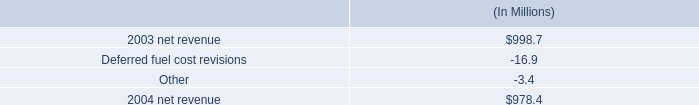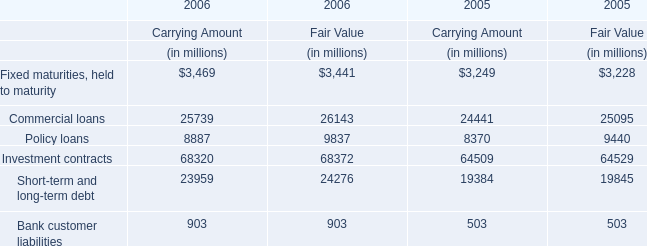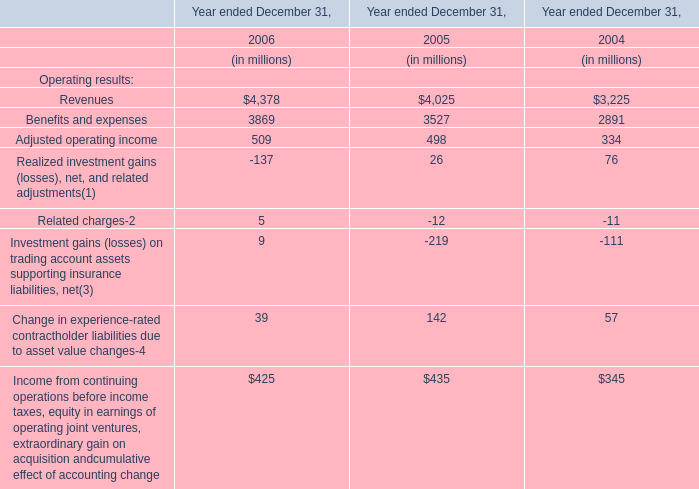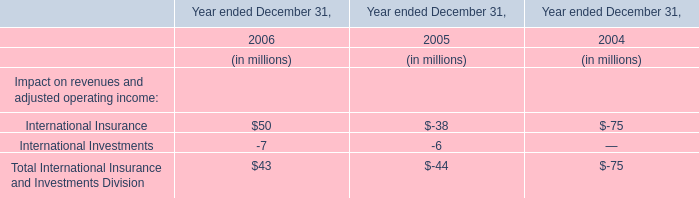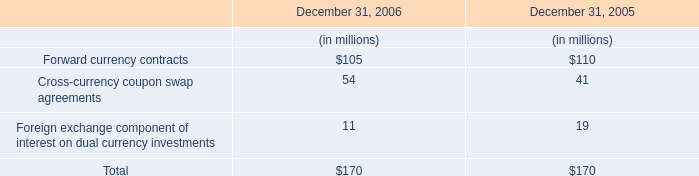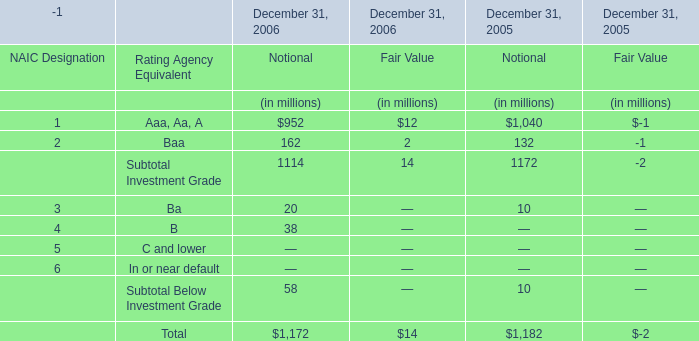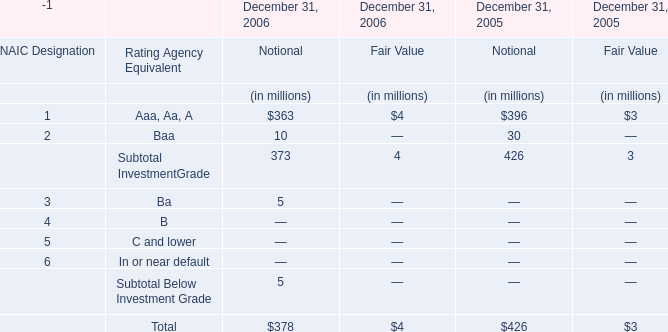what is the growth rate in net revenue in 2004 for entergy arkansas inc.? 
Computations: ((978.4 - 998.7) / 998.7)
Answer: -0.02033. 